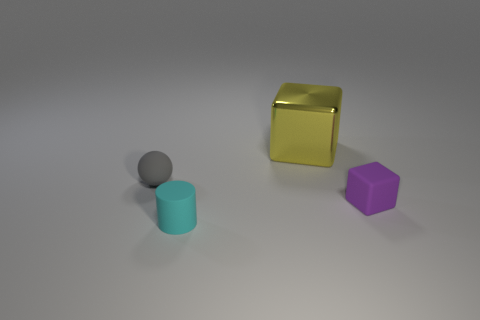Are there any other things that are made of the same material as the yellow block?
Offer a very short reply. No. Do the gray sphere and the block behind the small purple rubber cube have the same size?
Your answer should be compact. No. The small matte sphere on the left side of the object that is behind the gray thing is what color?
Make the answer very short. Gray. What number of other objects are the same color as the big cube?
Your response must be concise. 0. The shiny block is what size?
Offer a terse response. Large. Are there more tiny purple rubber objects in front of the matte cylinder than tiny gray spheres left of the tiny gray rubber sphere?
Your response must be concise. No. There is a tiny object that is right of the small cyan rubber cylinder; how many gray matte objects are on the right side of it?
Ensure brevity in your answer.  0. Is the shape of the tiny matte thing right of the yellow block the same as  the yellow object?
Offer a terse response. Yes. There is a purple thing that is the same shape as the yellow object; what is its material?
Provide a short and direct response. Rubber. What number of matte blocks have the same size as the cyan matte cylinder?
Ensure brevity in your answer.  1. 